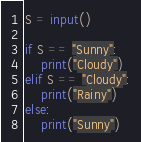Convert code to text. <code><loc_0><loc_0><loc_500><loc_500><_Python_>S = input()

if S == "Sunny":
    print("Cloudy")
elif S == "Cloudy":
    print("Rainy")
else:
    print("Sunny")</code> 